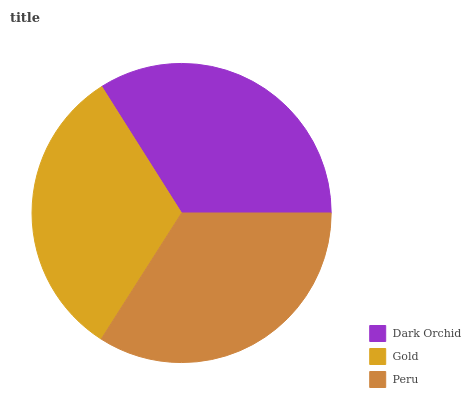Is Gold the minimum?
Answer yes or no. Yes. Is Peru the maximum?
Answer yes or no. Yes. Is Peru the minimum?
Answer yes or no. No. Is Gold the maximum?
Answer yes or no. No. Is Peru greater than Gold?
Answer yes or no. Yes. Is Gold less than Peru?
Answer yes or no. Yes. Is Gold greater than Peru?
Answer yes or no. No. Is Peru less than Gold?
Answer yes or no. No. Is Dark Orchid the high median?
Answer yes or no. Yes. Is Dark Orchid the low median?
Answer yes or no. Yes. Is Peru the high median?
Answer yes or no. No. Is Peru the low median?
Answer yes or no. No. 